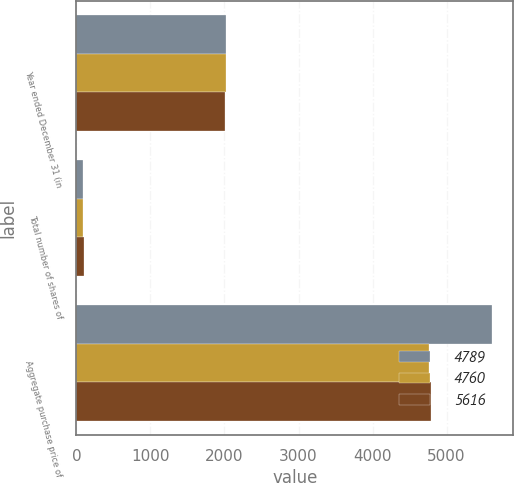Convert chart. <chart><loc_0><loc_0><loc_500><loc_500><stacked_bar_chart><ecel><fcel>Year ended December 31 (in<fcel>Total number of shares of<fcel>Aggregate purchase price of<nl><fcel>4789<fcel>2015<fcel>89.8<fcel>5616<nl><fcel>4760<fcel>2014<fcel>82.3<fcel>4760<nl><fcel>5616<fcel>2013<fcel>96.1<fcel>4789<nl></chart> 